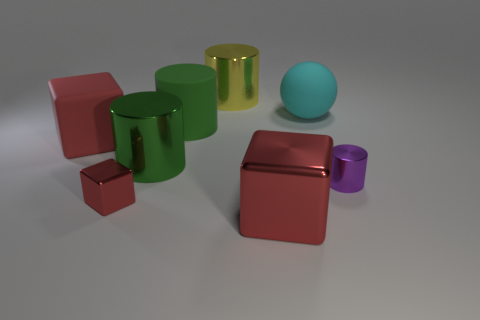How many red blocks must be subtracted to get 1 red blocks? 2 Add 2 small blue spheres. How many objects exist? 10 Subtract all blocks. How many objects are left? 5 Subtract all rubber cylinders. Subtract all large cyan matte things. How many objects are left? 6 Add 2 small metal things. How many small metal things are left? 4 Add 7 cyan objects. How many cyan objects exist? 8 Subtract 0 purple balls. How many objects are left? 8 